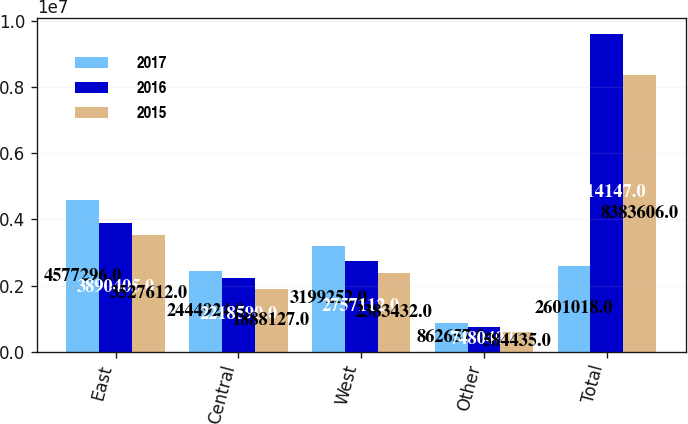Convert chart to OTSL. <chart><loc_0><loc_0><loc_500><loc_500><stacked_bar_chart><ecel><fcel>East<fcel>Central<fcel>West<fcel>Other<fcel>Total<nl><fcel>2017<fcel>4.5773e+06<fcel>2.44492e+06<fcel>3.19925e+06<fcel>862657<fcel>2.60102e+06<nl><fcel>2016<fcel>3.8904e+06<fcel>2.21859e+06<fcel>2.75711e+06<fcel>748040<fcel>9.61415e+06<nl><fcel>2015<fcel>3.52761e+06<fcel>1.88813e+06<fcel>2.38343e+06<fcel>584435<fcel>8.38361e+06<nl></chart> 